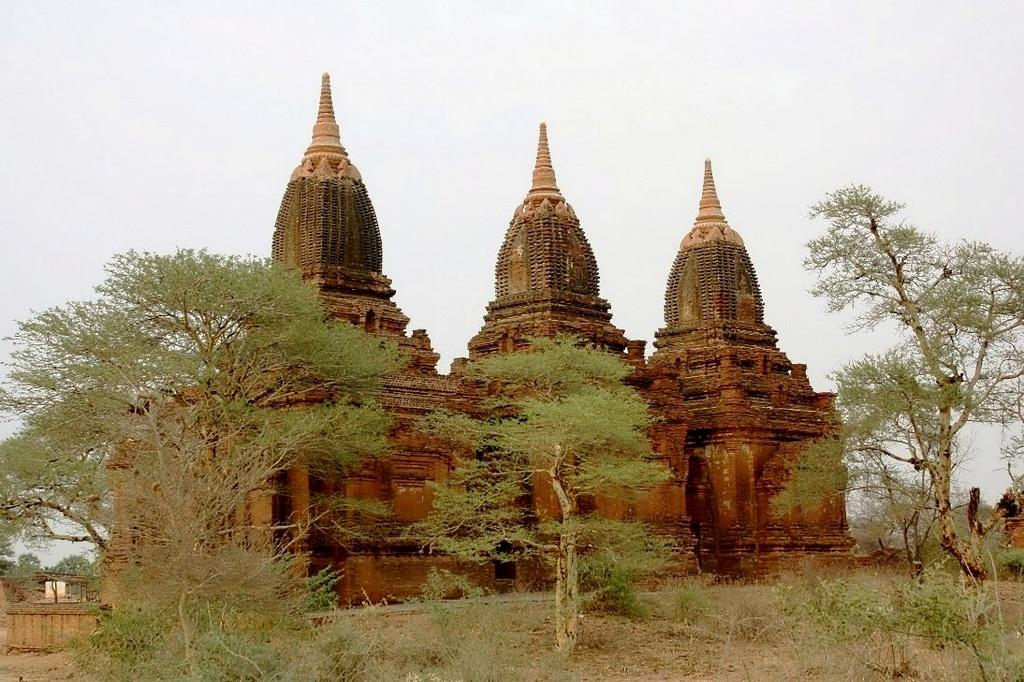How many temples can be seen in the image? There are three temples in the image. What other natural elements are present in the image besides the temples? There are trees in the image. What is the condition of the sky in the image? The sky is clear in the image. What type of yoke is being used by the person in the image? There is no person present in the image, and therefore no yoke can be observed. 